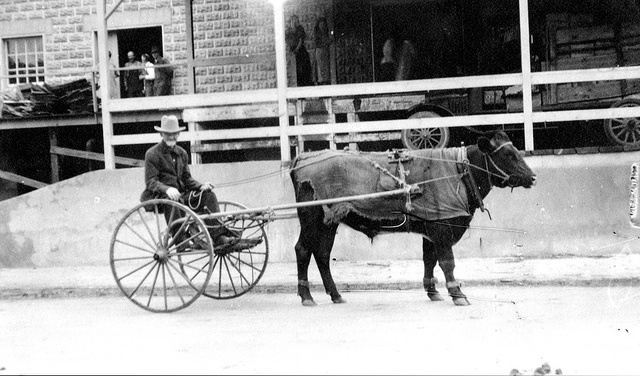Describe the objects in this image and their specific colors. I can see cow in darkgray, black, gray, and lightgray tones, people in darkgray, black, gray, and lightgray tones, car in darkgray, black, gray, and lightgray tones, people in darkgray, black, gray, and silver tones, and people in darkgray, black, gray, and lightgray tones in this image. 